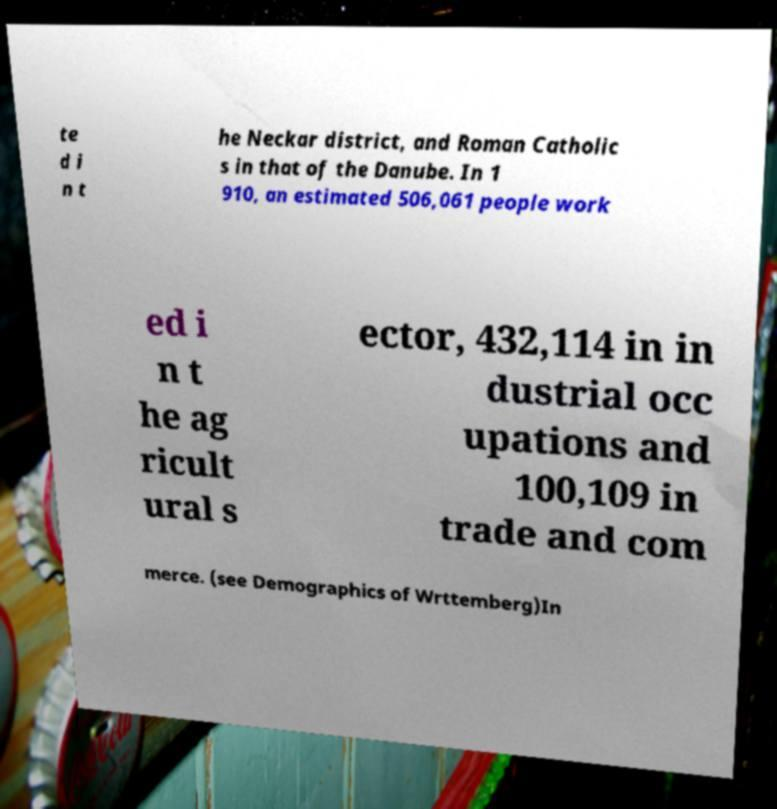Could you assist in decoding the text presented in this image and type it out clearly? te d i n t he Neckar district, and Roman Catholic s in that of the Danube. In 1 910, an estimated 506,061 people work ed i n t he ag ricult ural s ector, 432,114 in in dustrial occ upations and 100,109 in trade and com merce. (see Demographics of Wrttemberg)In 